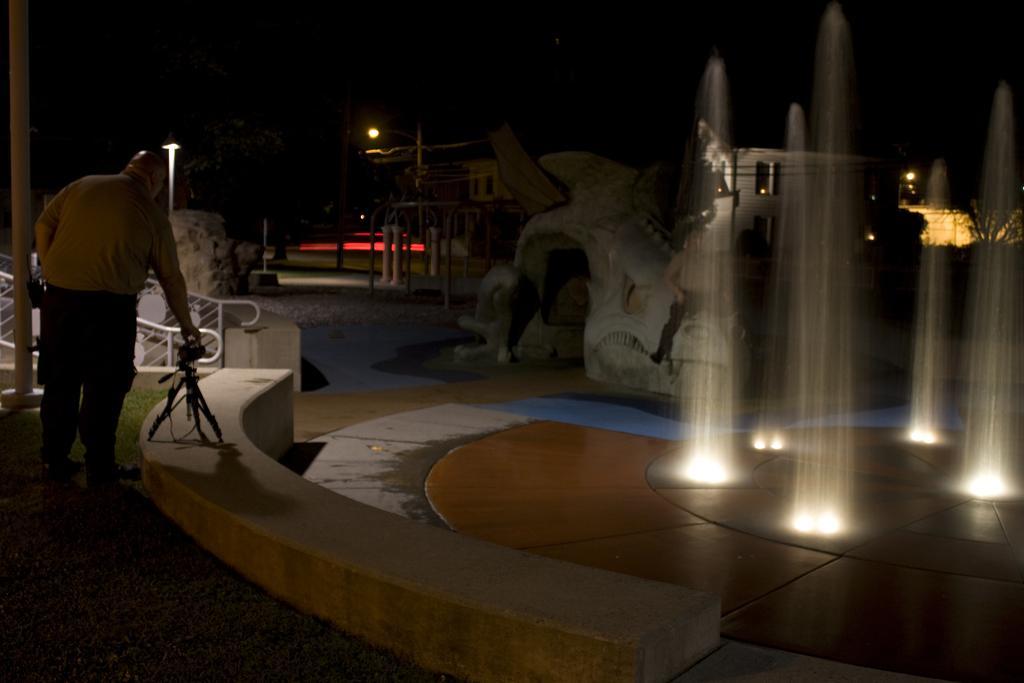How would you summarize this image in a sentence or two? On the right side of the image we can see a man. At the bottom there is a stand placed on the wall and there are railings. On the right there is a fountain. In the background there are buildings, lights and poles. 